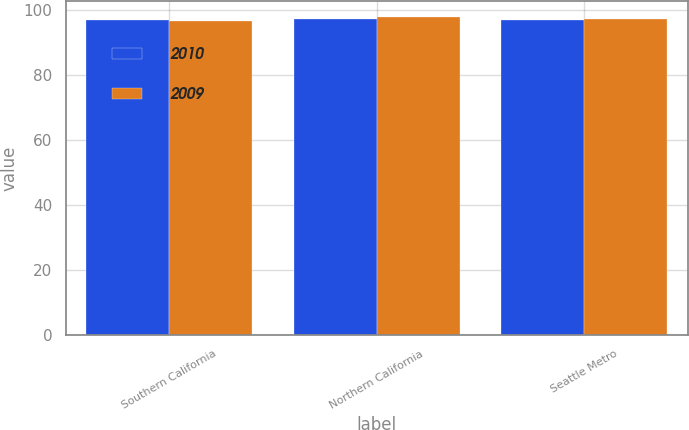Convert chart. <chart><loc_0><loc_0><loc_500><loc_500><stacked_bar_chart><ecel><fcel>Southern California<fcel>Northern California<fcel>Seattle Metro<nl><fcel>2010<fcel>96.8<fcel>97.3<fcel>96.9<nl><fcel>2009<fcel>96.6<fcel>97.7<fcel>97.1<nl></chart> 